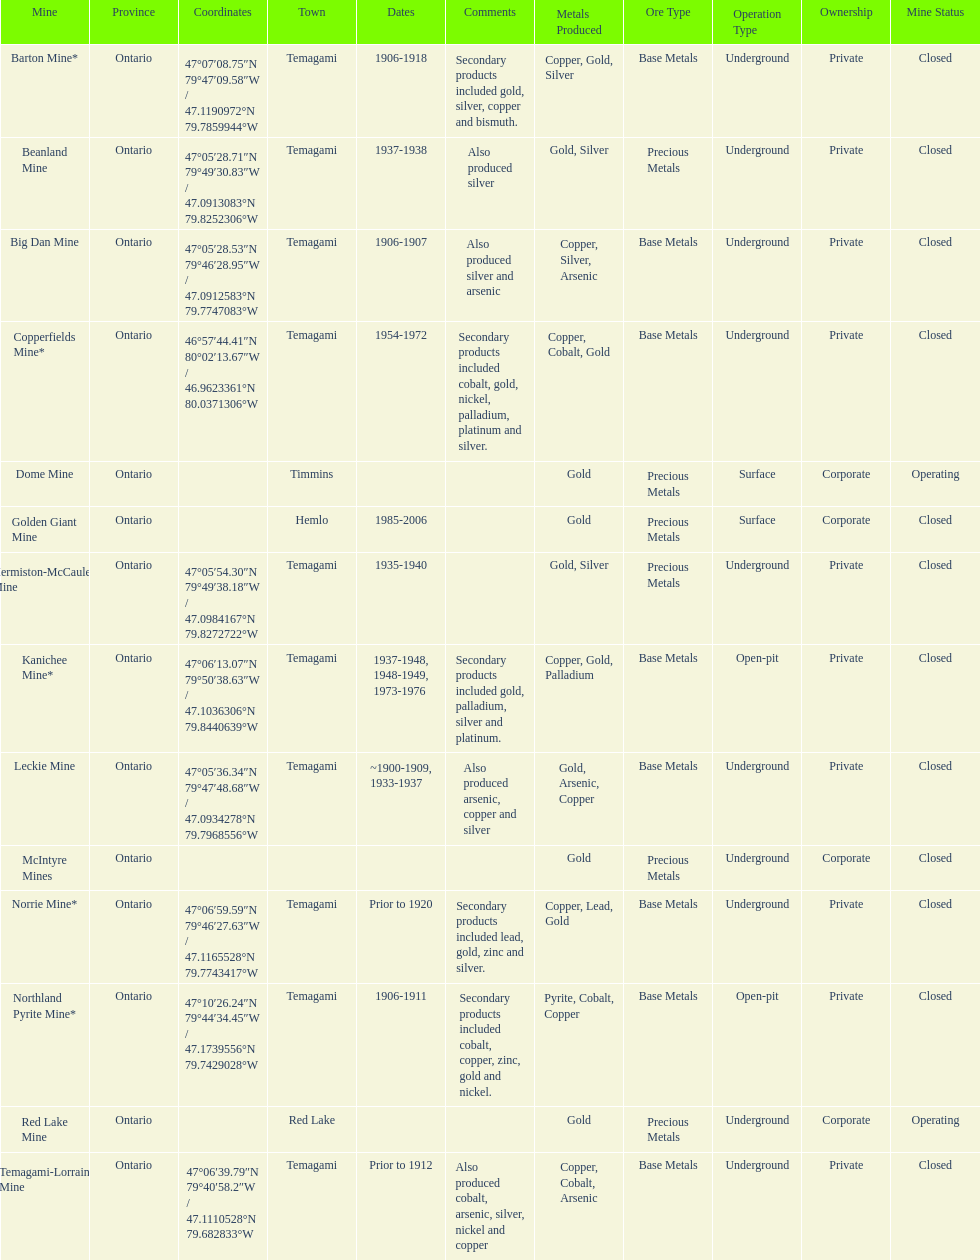Which mine was open longer, golden giant or beanland mine? Golden Giant Mine. Write the full table. {'header': ['Mine', 'Province', 'Coordinates', 'Town', 'Dates', 'Comments', 'Metals Produced', 'Ore Type', 'Operation Type', 'Ownership', 'Mine Status'], 'rows': [['Barton Mine*', 'Ontario', '47°07′08.75″N 79°47′09.58″W\ufeff / \ufeff47.1190972°N 79.7859944°W', 'Temagami', '1906-1918', 'Secondary products included gold, silver, copper and bismuth.', 'Copper, Gold, Silver', 'Base Metals', 'Underground', 'Private', 'Closed'], ['Beanland Mine', 'Ontario', '47°05′28.71″N 79°49′30.83″W\ufeff / \ufeff47.0913083°N 79.8252306°W', 'Temagami', '1937-1938', 'Also produced silver', 'Gold, Silver', 'Precious Metals', 'Underground', 'Private', 'Closed'], ['Big Dan Mine', 'Ontario', '47°05′28.53″N 79°46′28.95″W\ufeff / \ufeff47.0912583°N 79.7747083°W', 'Temagami', '1906-1907', 'Also produced silver and arsenic', 'Copper, Silver, Arsenic', 'Base Metals', 'Underground', 'Private', 'Closed'], ['Copperfields Mine*', 'Ontario', '46°57′44.41″N 80°02′13.67″W\ufeff / \ufeff46.9623361°N 80.0371306°W', 'Temagami', '1954-1972', 'Secondary products included cobalt, gold, nickel, palladium, platinum and silver.', 'Copper, Cobalt, Gold', 'Base Metals', 'Underground', 'Private', 'Closed'], ['Dome Mine', 'Ontario', '', 'Timmins', '', '', 'Gold', 'Precious Metals', 'Surface', 'Corporate', 'Operating'], ['Golden Giant Mine', 'Ontario', '', 'Hemlo', '1985-2006', '', 'Gold', 'Precious Metals', 'Surface', 'Corporate', 'Closed'], ['Hermiston-McCauley Mine', 'Ontario', '47°05′54.30″N 79°49′38.18″W\ufeff / \ufeff47.0984167°N 79.8272722°W', 'Temagami', '1935-1940', '', 'Gold, Silver', 'Precious Metals', 'Underground', 'Private', 'Closed'], ['Kanichee Mine*', 'Ontario', '47°06′13.07″N 79°50′38.63″W\ufeff / \ufeff47.1036306°N 79.8440639°W', 'Temagami', '1937-1948, 1948-1949, 1973-1976', 'Secondary products included gold, palladium, silver and platinum.', 'Copper, Gold, Palladium', 'Base Metals', 'Open-pit', 'Private', 'Closed'], ['Leckie Mine', 'Ontario', '47°05′36.34″N 79°47′48.68″W\ufeff / \ufeff47.0934278°N 79.7968556°W', 'Temagami', '~1900-1909, 1933-1937', 'Also produced arsenic, copper and silver', 'Gold, Arsenic, Copper', 'Base Metals', 'Underground', 'Private', 'Closed'], ['McIntyre Mines', 'Ontario', '', '', '', '', 'Gold', 'Precious Metals', 'Underground', 'Corporate', 'Closed'], ['Norrie Mine*', 'Ontario', '47°06′59.59″N 79°46′27.63″W\ufeff / \ufeff47.1165528°N 79.7743417°W', 'Temagami', 'Prior to 1920', 'Secondary products included lead, gold, zinc and silver.', 'Copper, Lead, Gold', 'Base Metals', 'Underground', 'Private', 'Closed'], ['Northland Pyrite Mine*', 'Ontario', '47°10′26.24″N 79°44′34.45″W\ufeff / \ufeff47.1739556°N 79.7429028°W', 'Temagami', '1906-1911', 'Secondary products included cobalt, copper, zinc, gold and nickel.', 'Pyrite, Cobalt, Copper', 'Base Metals', 'Open-pit', 'Private', 'Closed'], ['Red Lake Mine', 'Ontario', '', 'Red Lake', '', '', 'Gold', 'Precious Metals', 'Underground', 'Corporate', 'Operating'], ['Temagami-Lorrain Mine', 'Ontario', '47°06′39.79″N 79°40′58.2″W\ufeff / \ufeff47.1110528°N 79.682833°W', 'Temagami', 'Prior to 1912', 'Also produced cobalt, arsenic, silver, nickel and copper', 'Copper, Cobalt, Arsenic', 'Base Metals', 'Underground', 'Private', 'Closed']]} 